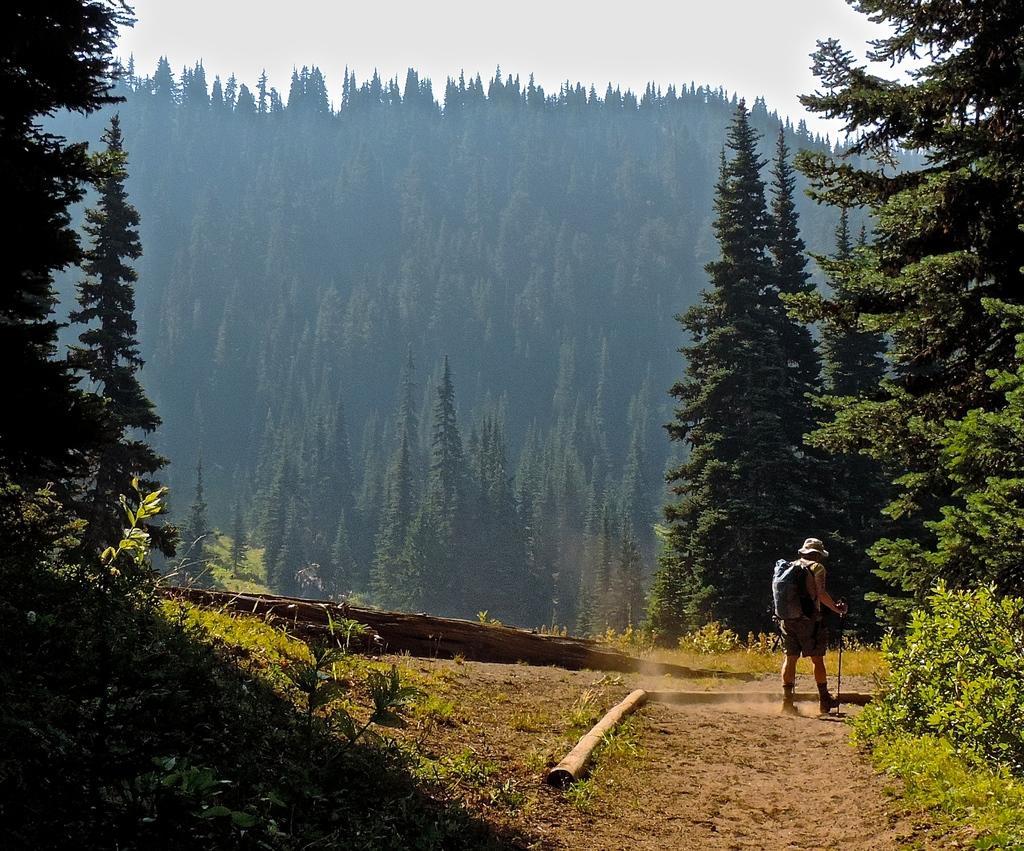Can you describe this image briefly? In this image, we can see hills, trees and there are logs and we can see a person wearing a bag and a cap and holding a stick. 